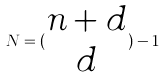<formula> <loc_0><loc_0><loc_500><loc_500>N = ( \begin{matrix} n + d \\ d \end{matrix} ) - 1</formula> 